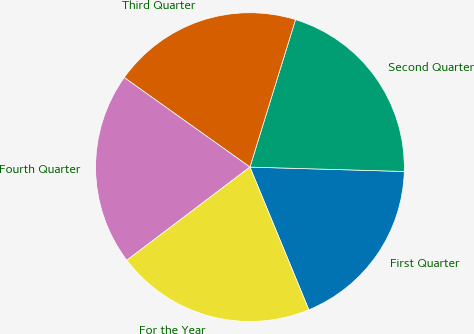Convert chart to OTSL. <chart><loc_0><loc_0><loc_500><loc_500><pie_chart><fcel>First Quarter<fcel>Second Quarter<fcel>Third Quarter<fcel>Fourth Quarter<fcel>For the Year<nl><fcel>18.32%<fcel>20.68%<fcel>19.92%<fcel>20.16%<fcel>20.92%<nl></chart> 